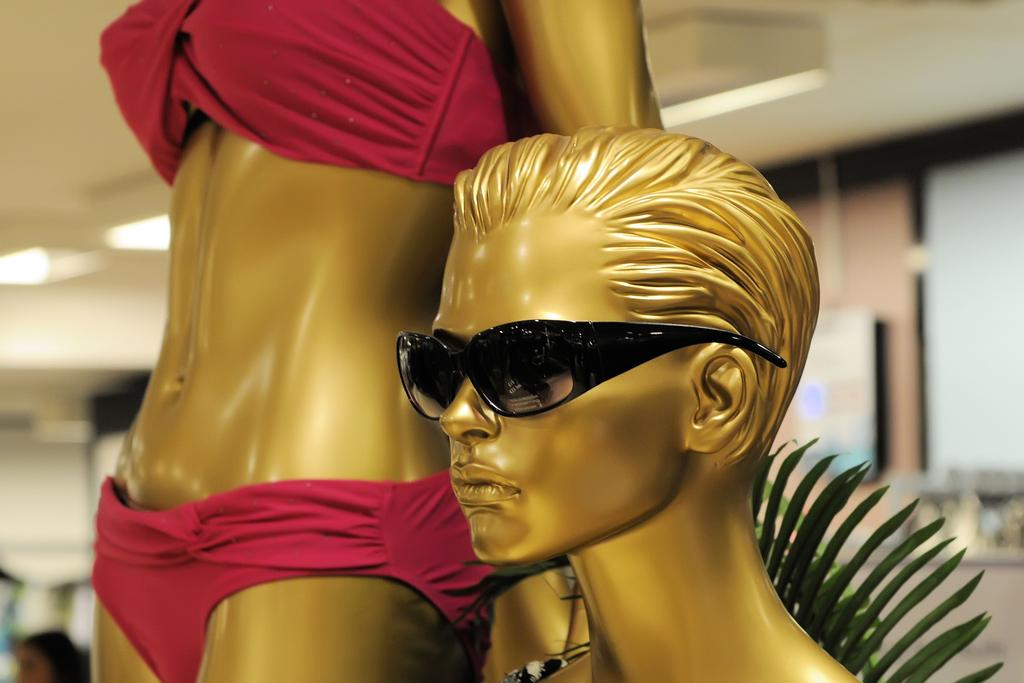What type of figures can be seen in the image? There are mannequins in the image. How would you describe the background of the image? The background is blurred. What can be seen illuminating the scene in the image? There are lights visible in the image. What type of architectural element is present in the image? There is a wall in the image. What part of the room is visible from above in the image? The ceiling is visible in the image. What type of appliance is being used by the mannequins in the image? There are no appliances present in the image; it only features mannequins, lights, and architectural elements. 